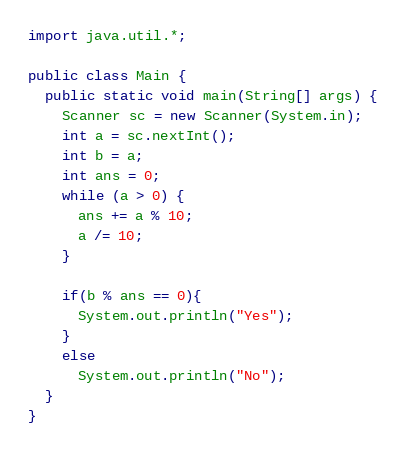Convert code to text. <code><loc_0><loc_0><loc_500><loc_500><_Java_>import java.util.*;

public class Main {
  public static void main(String[] args) {
    Scanner sc = new Scanner(System.in);
    int a = sc.nextInt();
    int b = a;
    int ans = 0;
    while (a > 0) {
      ans += a % 10;
      a /= 10;
    }
    
    if(b % ans == 0){
      System.out.println("Yes");
    }
    else
      System.out.println("No");
  }
}
</code> 